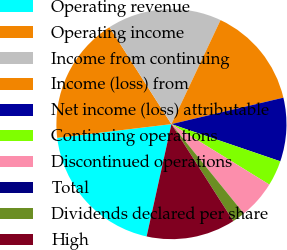<chart> <loc_0><loc_0><loc_500><loc_500><pie_chart><fcel>Operating revenue<fcel>Operating income<fcel>Income from continuing<fcel>Income (loss) from<fcel>Net income (loss) attributable<fcel>Continuing operations<fcel>Discontinued operations<fcel>Total<fcel>Dividends declared per share<fcel>High<nl><fcel>19.64%<fcel>17.86%<fcel>16.07%<fcel>14.29%<fcel>8.93%<fcel>3.57%<fcel>5.36%<fcel>0.0%<fcel>1.79%<fcel>12.5%<nl></chart> 